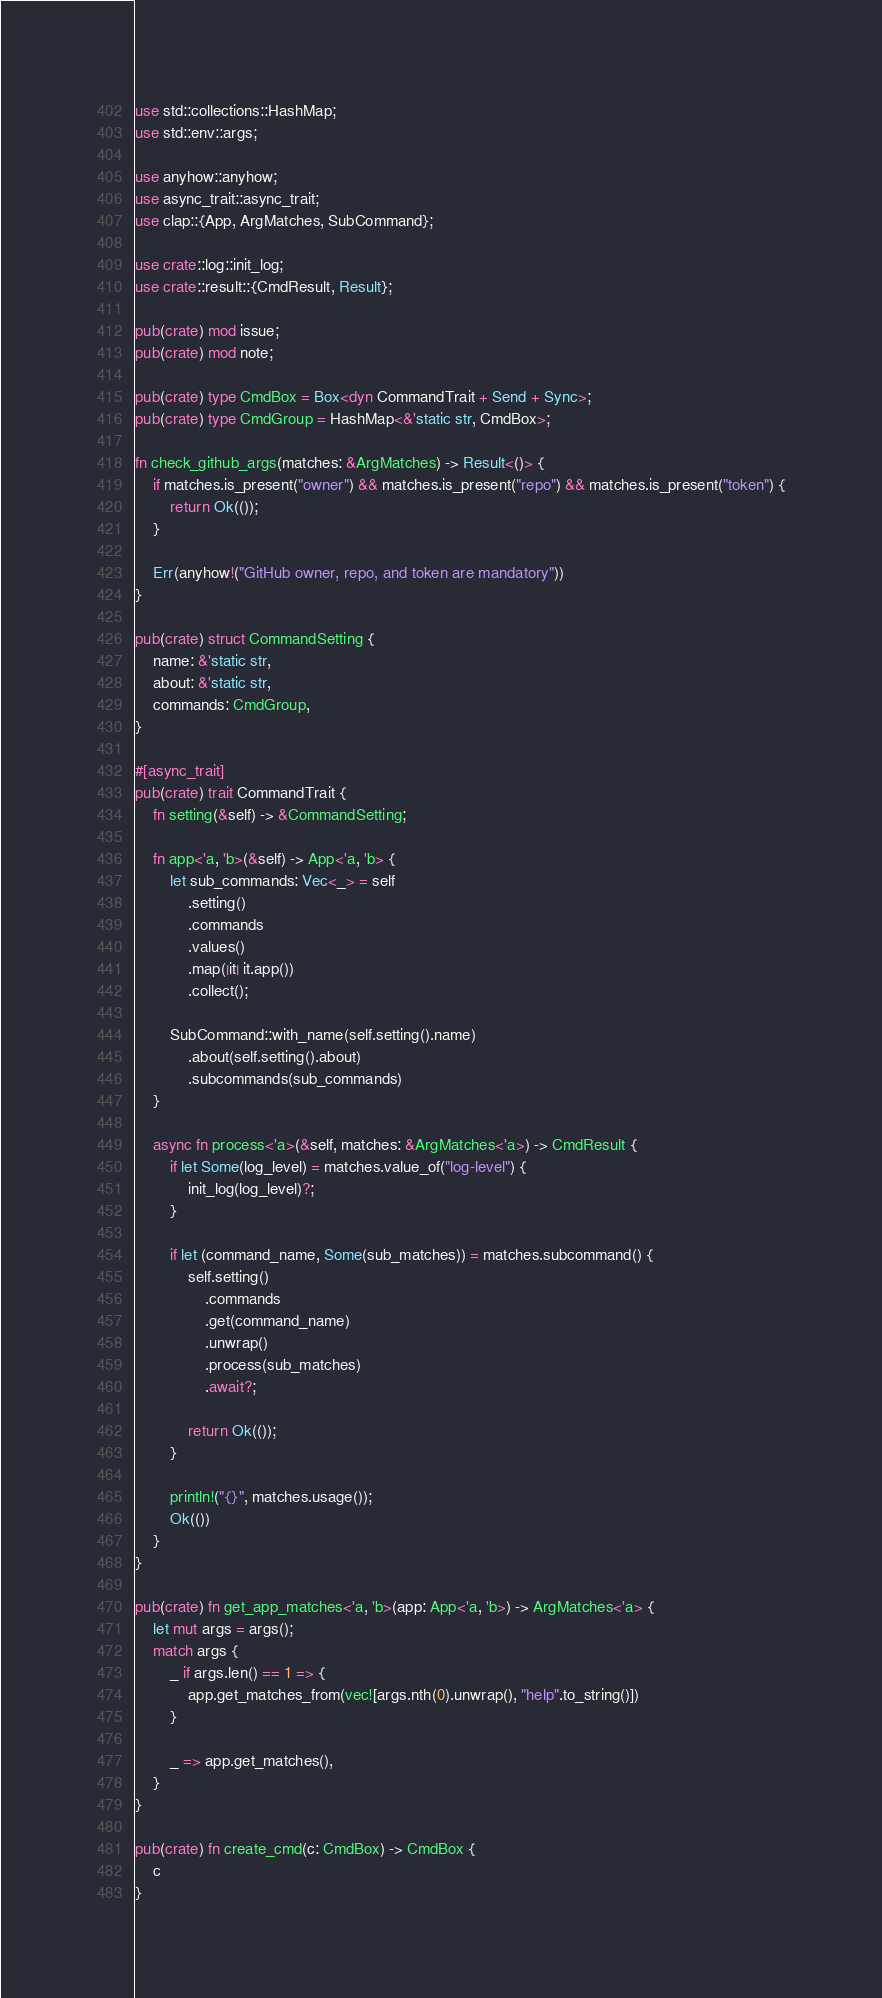Convert code to text. <code><loc_0><loc_0><loc_500><loc_500><_Rust_>use std::collections::HashMap;
use std::env::args;

use anyhow::anyhow;
use async_trait::async_trait;
use clap::{App, ArgMatches, SubCommand};

use crate::log::init_log;
use crate::result::{CmdResult, Result};

pub(crate) mod issue;
pub(crate) mod note;

pub(crate) type CmdBox = Box<dyn CommandTrait + Send + Sync>;
pub(crate) type CmdGroup = HashMap<&'static str, CmdBox>;

fn check_github_args(matches: &ArgMatches) -> Result<()> {
    if matches.is_present("owner") && matches.is_present("repo") && matches.is_present("token") {
        return Ok(());
    }

    Err(anyhow!("GitHub owner, repo, and token are mandatory"))
}

pub(crate) struct CommandSetting {
    name: &'static str,
    about: &'static str,
    commands: CmdGroup,
}

#[async_trait]
pub(crate) trait CommandTrait {
    fn setting(&self) -> &CommandSetting;

    fn app<'a, 'b>(&self) -> App<'a, 'b> {
        let sub_commands: Vec<_> = self
            .setting()
            .commands
            .values()
            .map(|it| it.app())
            .collect();

        SubCommand::with_name(self.setting().name)
            .about(self.setting().about)
            .subcommands(sub_commands)
    }

    async fn process<'a>(&self, matches: &ArgMatches<'a>) -> CmdResult {
        if let Some(log_level) = matches.value_of("log-level") {
            init_log(log_level)?;
        }

        if let (command_name, Some(sub_matches)) = matches.subcommand() {
            self.setting()
                .commands
                .get(command_name)
                .unwrap()
                .process(sub_matches)
                .await?;

            return Ok(());
        }

        println!("{}", matches.usage());
        Ok(())
    }
}

pub(crate) fn get_app_matches<'a, 'b>(app: App<'a, 'b>) -> ArgMatches<'a> {
    let mut args = args();
    match args {
        _ if args.len() == 1 => {
            app.get_matches_from(vec![args.nth(0).unwrap(), "help".to_string()])
        }

        _ => app.get_matches(),
    }
}

pub(crate) fn create_cmd(c: CmdBox) -> CmdBox {
    c
}
</code> 